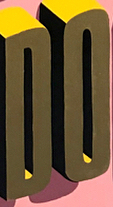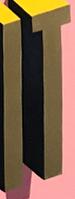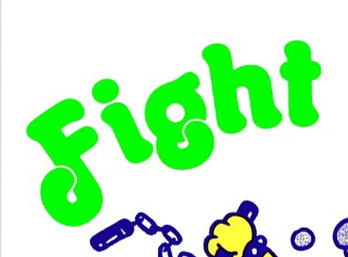What words can you see in these images in sequence, separated by a semicolon? DO; IT; Fight 